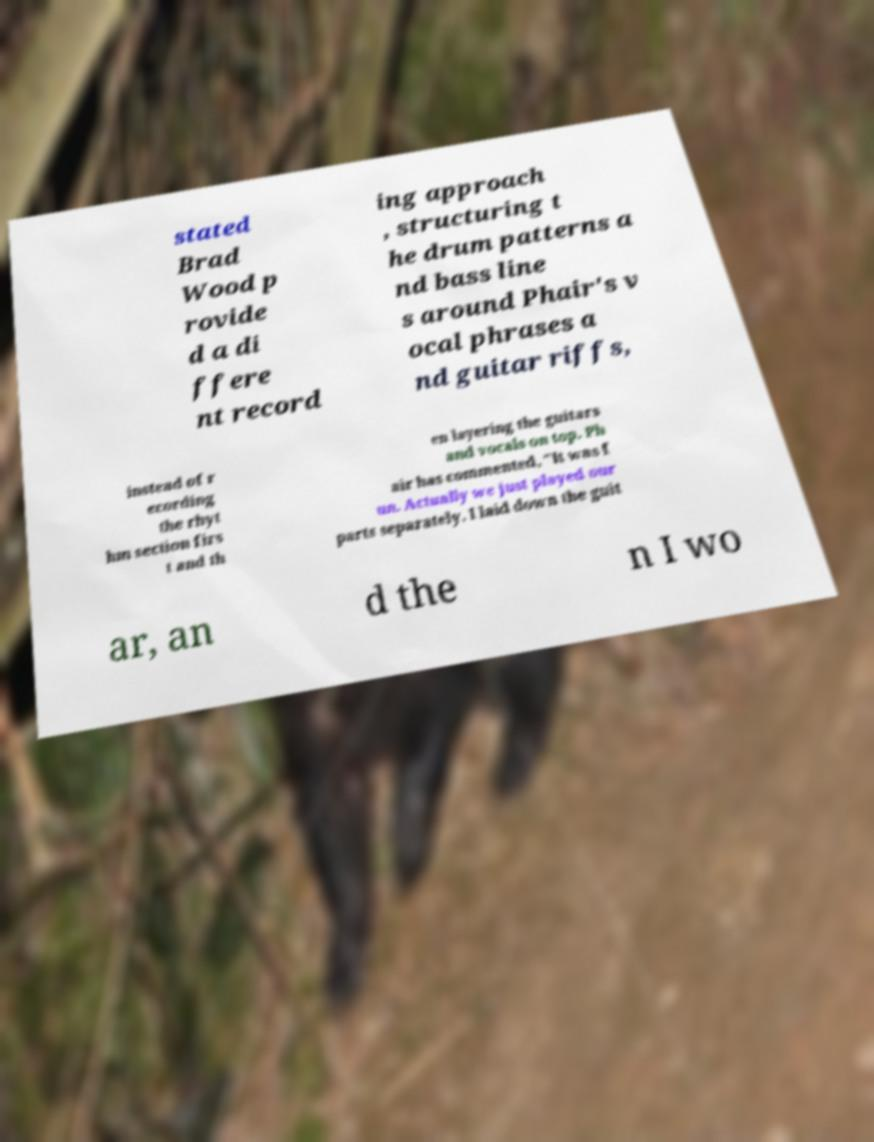For documentation purposes, I need the text within this image transcribed. Could you provide that? stated Brad Wood p rovide d a di ffere nt record ing approach , structuring t he drum patterns a nd bass line s around Phair's v ocal phrases a nd guitar riffs, instead of r ecording the rhyt hm section firs t and th en layering the guitars and vocals on top. Ph air has commented, "It was f un. Actually we just played our parts separately. I laid down the guit ar, an d the n I wo 